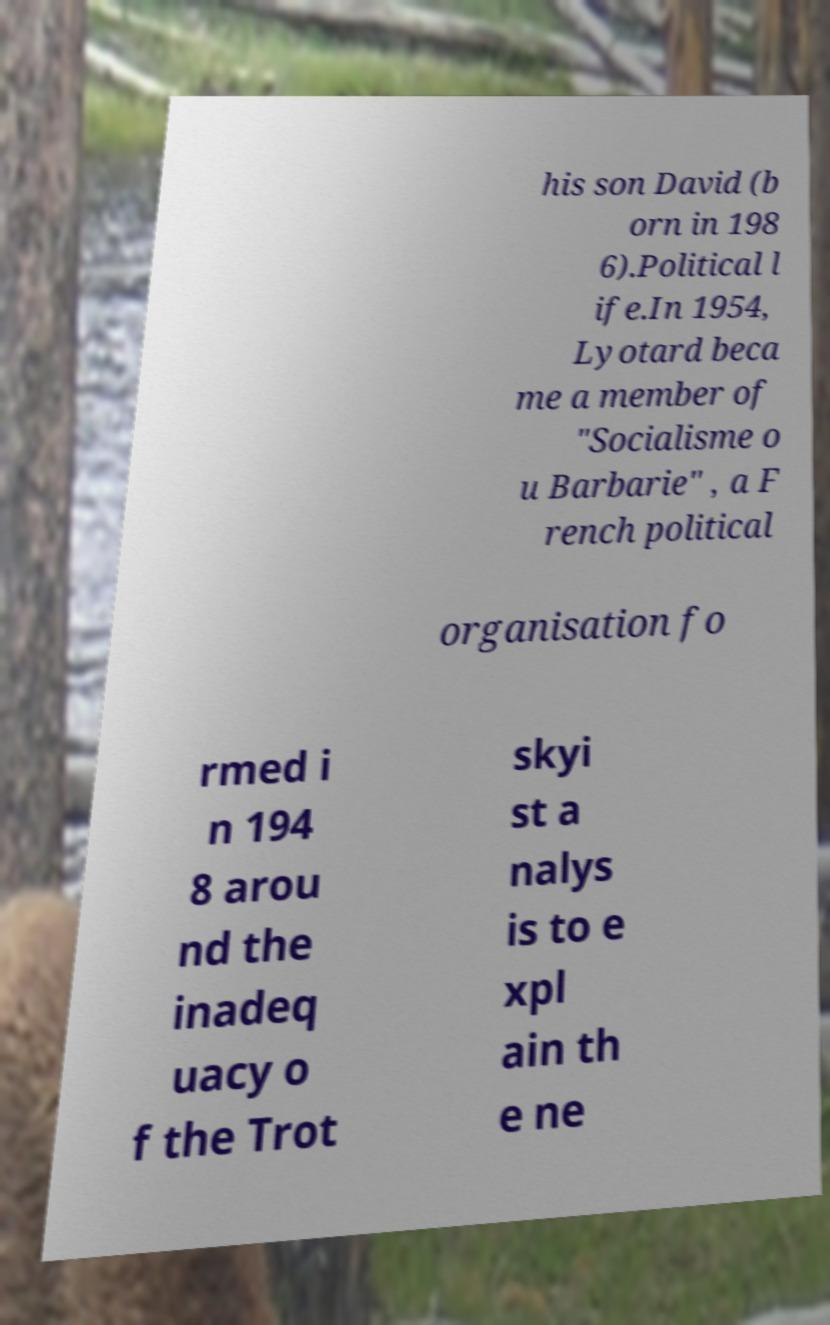What messages or text are displayed in this image? I need them in a readable, typed format. his son David (b orn in 198 6).Political l ife.In 1954, Lyotard beca me a member of "Socialisme o u Barbarie" , a F rench political organisation fo rmed i n 194 8 arou nd the inadeq uacy o f the Trot skyi st a nalys is to e xpl ain th e ne 